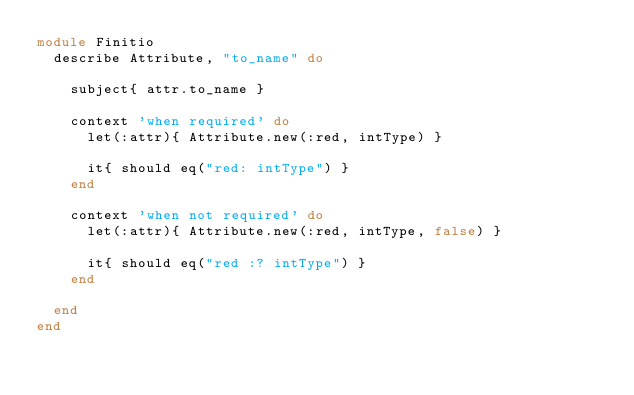Convert code to text. <code><loc_0><loc_0><loc_500><loc_500><_Ruby_>module Finitio
  describe Attribute, "to_name" do

    subject{ attr.to_name }

    context 'when required' do
      let(:attr){ Attribute.new(:red, intType) }

      it{ should eq("red: intType") }
    end

    context 'when not required' do
      let(:attr){ Attribute.new(:red, intType, false) }

      it{ should eq("red :? intType") }
    end

  end
end
</code> 